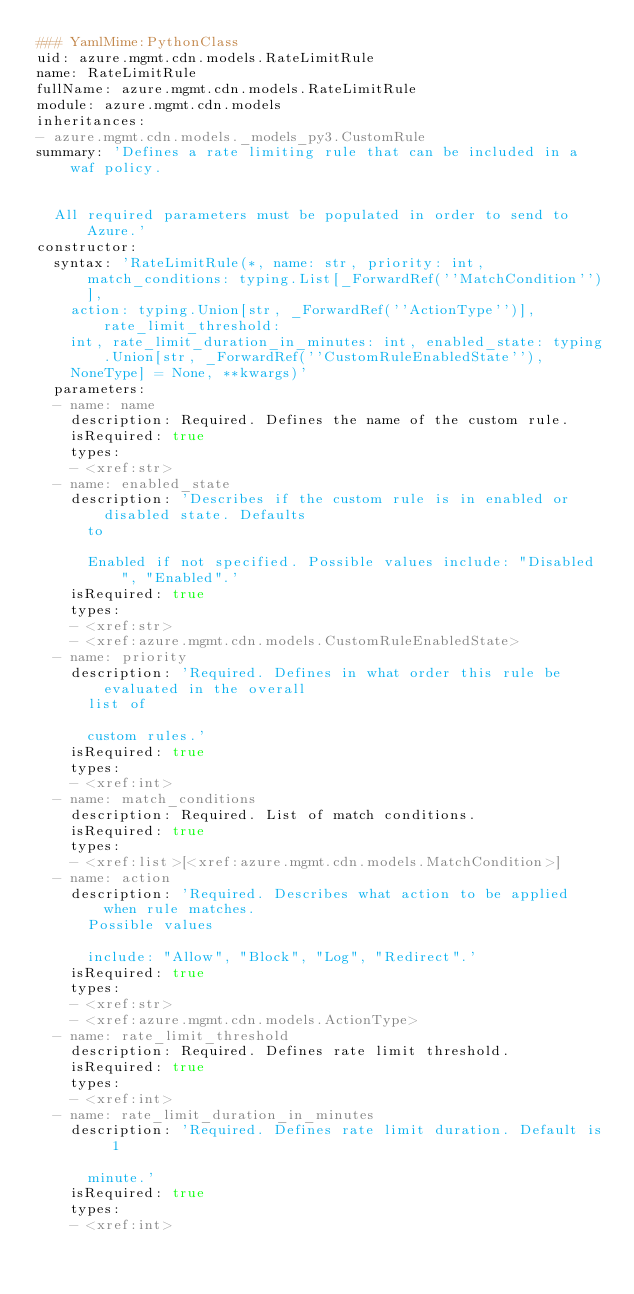<code> <loc_0><loc_0><loc_500><loc_500><_YAML_>### YamlMime:PythonClass
uid: azure.mgmt.cdn.models.RateLimitRule
name: RateLimitRule
fullName: azure.mgmt.cdn.models.RateLimitRule
module: azure.mgmt.cdn.models
inheritances:
- azure.mgmt.cdn.models._models_py3.CustomRule
summary: 'Defines a rate limiting rule that can be included in a waf policy.


  All required parameters must be populated in order to send to Azure.'
constructor:
  syntax: 'RateLimitRule(*, name: str, priority: int, match_conditions: typing.List[_ForwardRef(''MatchCondition'')],
    action: typing.Union[str, _ForwardRef(''ActionType'')], rate_limit_threshold:
    int, rate_limit_duration_in_minutes: int, enabled_state: typing.Union[str, _ForwardRef(''CustomRuleEnabledState''),
    NoneType] = None, **kwargs)'
  parameters:
  - name: name
    description: Required. Defines the name of the custom rule.
    isRequired: true
    types:
    - <xref:str>
  - name: enabled_state
    description: 'Describes if the custom rule is in enabled or disabled state. Defaults
      to

      Enabled if not specified. Possible values include: "Disabled", "Enabled".'
    isRequired: true
    types:
    - <xref:str>
    - <xref:azure.mgmt.cdn.models.CustomRuleEnabledState>
  - name: priority
    description: 'Required. Defines in what order this rule be evaluated in the overall
      list of

      custom rules.'
    isRequired: true
    types:
    - <xref:int>
  - name: match_conditions
    description: Required. List of match conditions.
    isRequired: true
    types:
    - <xref:list>[<xref:azure.mgmt.cdn.models.MatchCondition>]
  - name: action
    description: 'Required. Describes what action to be applied when rule matches.
      Possible values

      include: "Allow", "Block", "Log", "Redirect".'
    isRequired: true
    types:
    - <xref:str>
    - <xref:azure.mgmt.cdn.models.ActionType>
  - name: rate_limit_threshold
    description: Required. Defines rate limit threshold.
    isRequired: true
    types:
    - <xref:int>
  - name: rate_limit_duration_in_minutes
    description: 'Required. Defines rate limit duration. Default is 1

      minute.'
    isRequired: true
    types:
    - <xref:int>
</code> 